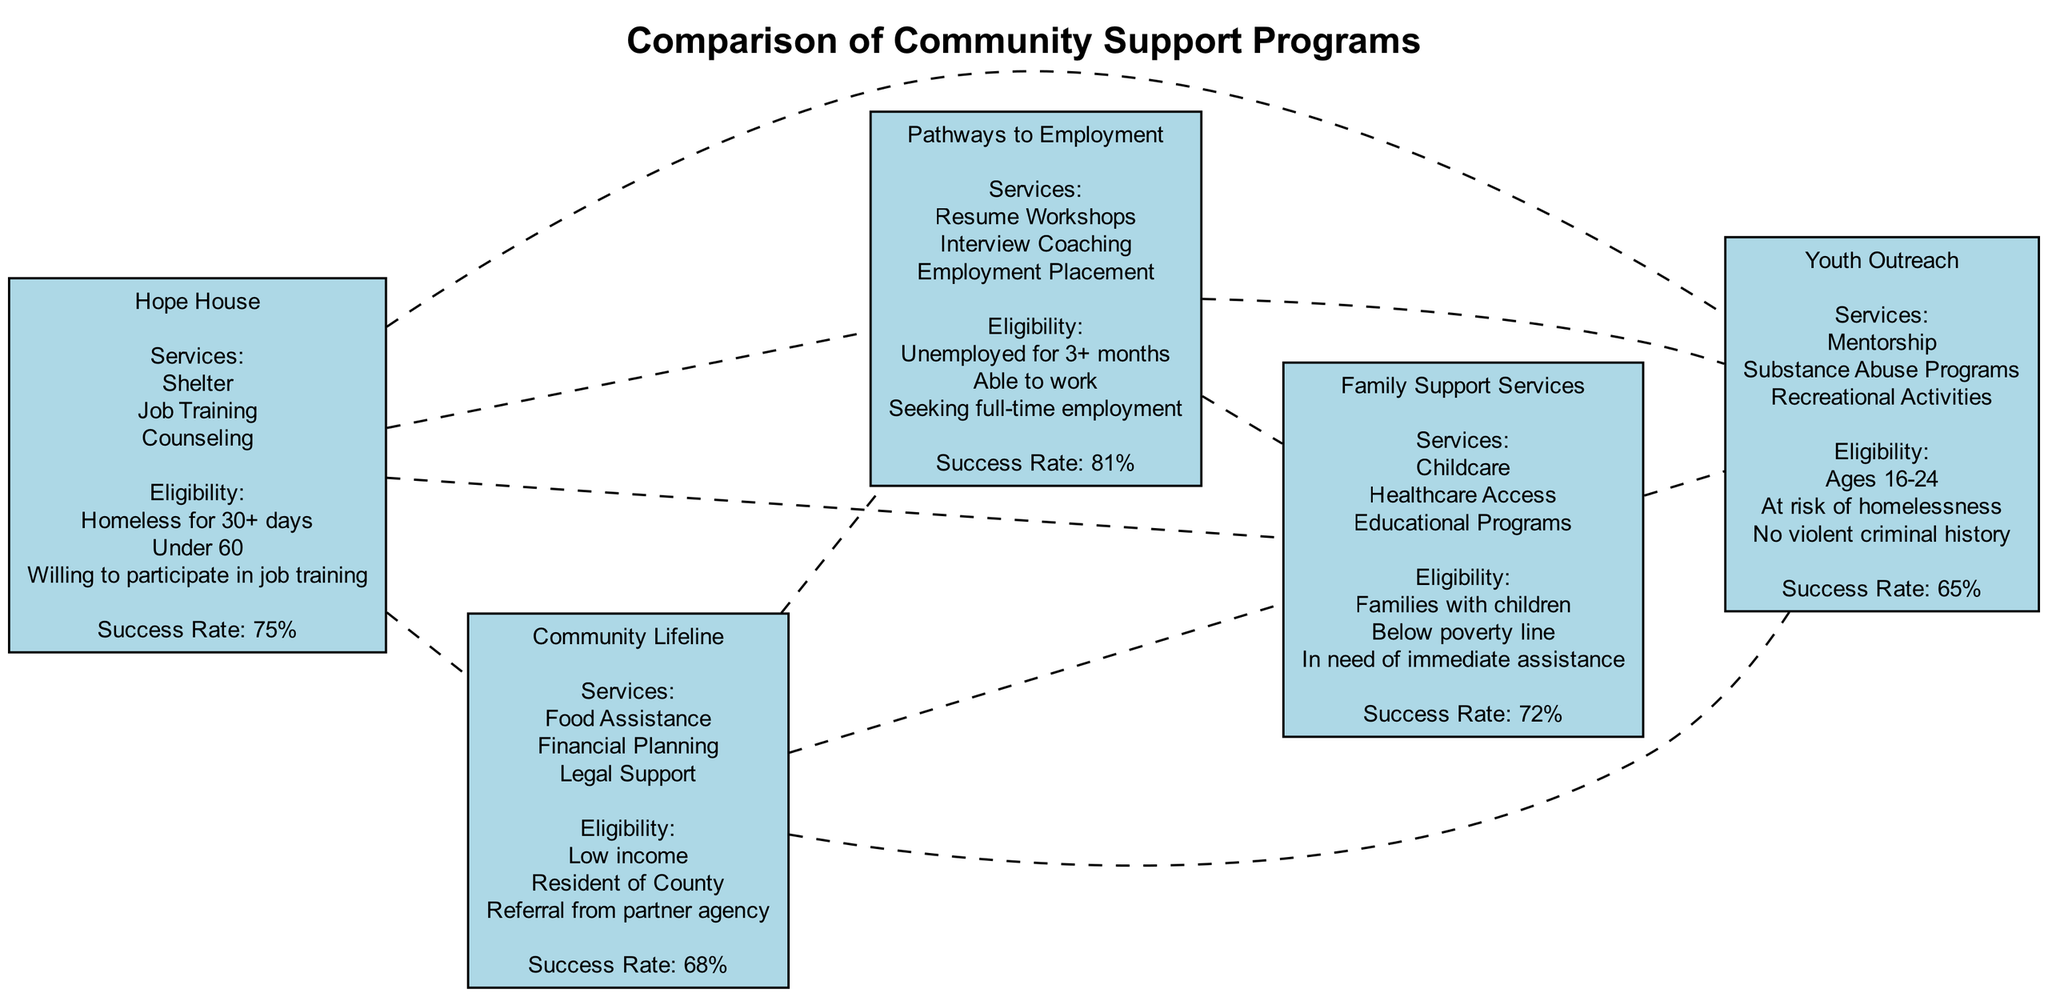What services does Hope House offer? The diagram lists the services offered by each program. For Hope House, the services include Shelter, Job Training, and Counseling.
Answer: Shelter, Job Training, Counseling What is the success rate of Pathways to Employment? By checking the specific node for Pathways to Employment in the diagram, we see it states a success rate of 81%.
Answer: 81% Which program requires a referral from a partner agency? Looking at the eligibility criteria for each program, Community Lifeline specifically mentions the need for a referral from a partner agency.
Answer: Community Lifeline How many programs offer job training services? The diagram can be analyzed for services offered. Hope House and Pathways to Employment both include job training in their services. Therefore, the total is two programs.
Answer: 2 What is the lowest success rate among the programs? The success rates for all programs are compared. Youth Outreach has the lowest success rate at 65%, making it the answer.
Answer: 65% Which program is available for families with children? Examining the eligibility criteria for each program shows that Family Support Services is the program specifically designated for families with children.
Answer: Family Support Services What eligibility criteria is common to Hope House and Pathways to Employment? Both programs have the eligibility criterion of participants being willing to work or actively seek employment. This commonality highlights a shared focus on workforce reintegration.
Answer: Willing to work / Seeking employment How many nodes are in the diagram? Count the individual programs represented as nodes. There are five programs in total: Hope House, Community Lifeline, Pathways to Employment, Family Support Services, and Youth Outreach.
Answer: 5 What type of programs does Youth Outreach focus on? Youth Outreach explicitly focuses on services like Mentorship, Substance Abuse Programs, and Recreational Activities aimed at youth aged 16-24.
Answer: Youth Programs 